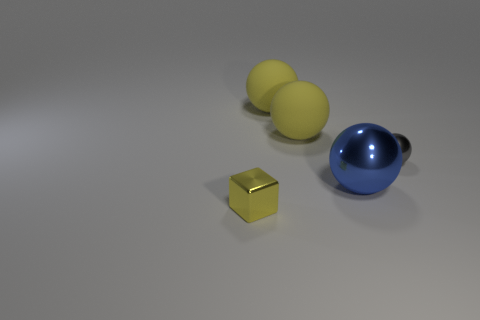Subtract all gray balls. How many balls are left? 3 Subtract all small spheres. How many spheres are left? 3 Subtract all cyan balls. Subtract all brown cylinders. How many balls are left? 4 Add 4 yellow metal cubes. How many objects exist? 9 Subtract all cubes. How many objects are left? 4 Add 4 rubber things. How many rubber things exist? 6 Subtract 0 green blocks. How many objects are left? 5 Subtract all large blue balls. Subtract all balls. How many objects are left? 0 Add 5 gray shiny balls. How many gray shiny balls are left? 6 